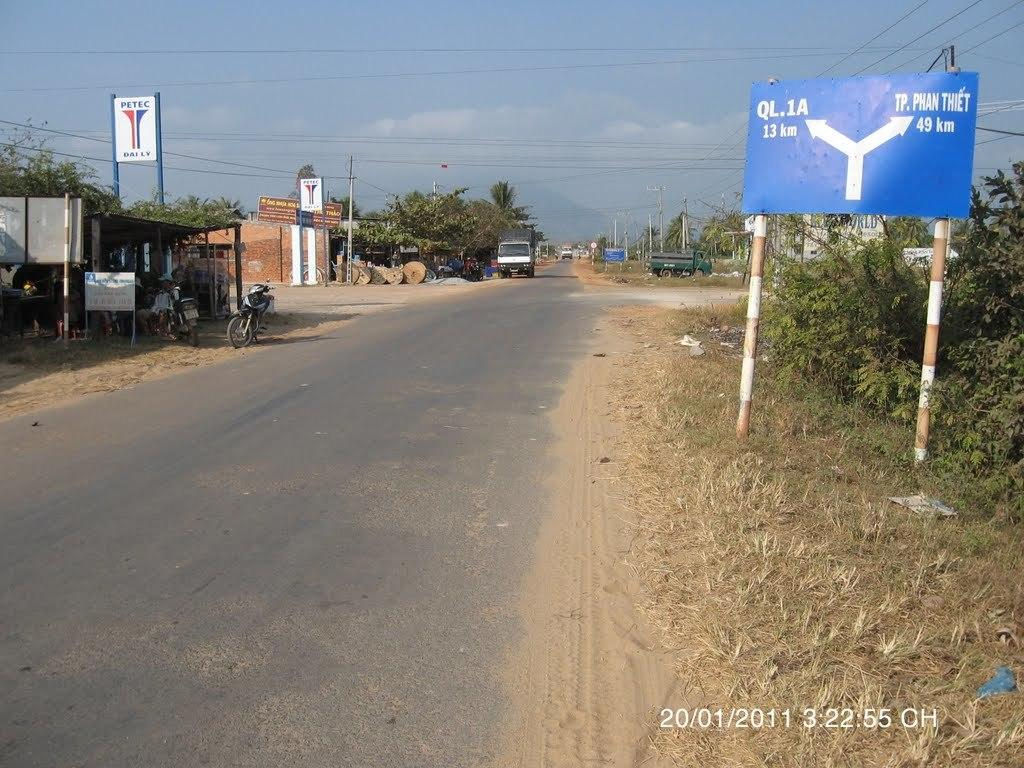<image>
Give a short and clear explanation of the subsequent image. The picture of the road was taken on January 1st, 2011. 